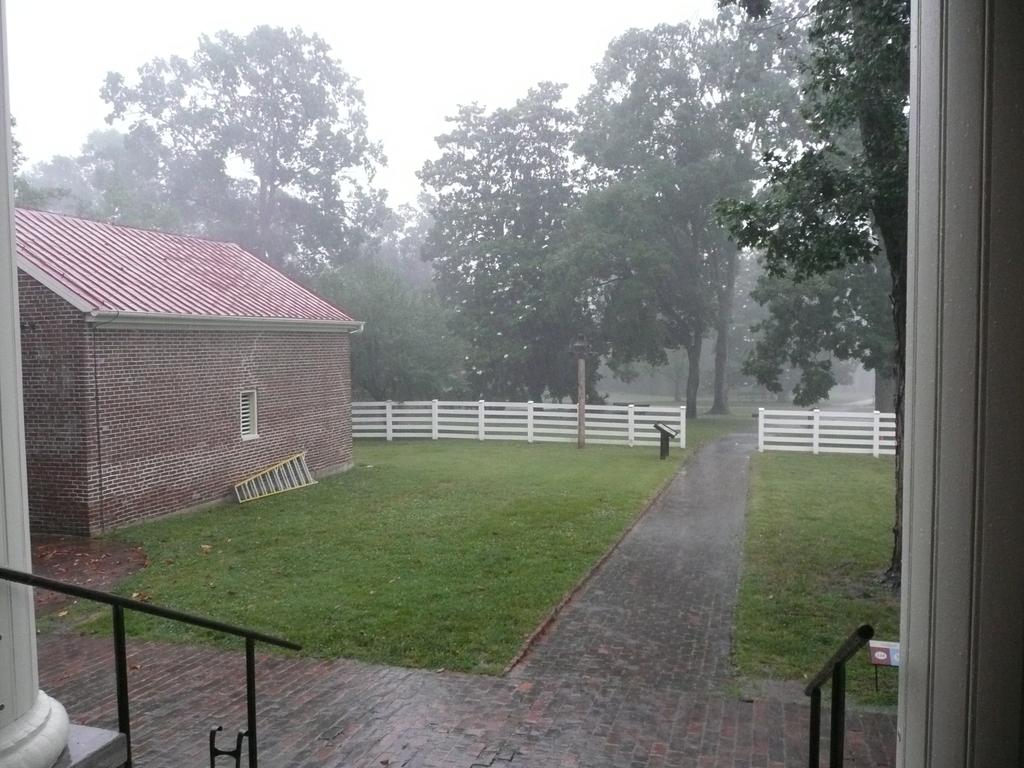What type of structure is in the picture? There is a house in the picture. What architectural features can be seen in the picture? There are pillars in the picture. What is used for climbing or reaching higher places in the picture? There is a ladder in the picture. What type of barrier is present in the picture? There is a fence in the picture. What type of vegetation is in the picture? There are trees in the picture. What is visible in the background of the picture? The sky is visible in the background of the picture. What type of knee injury can be seen in the picture? There is no knee injury present in the picture; it features a house, pillars, a ladder, a fence, trees, and the sky. What type of jewel is being worn by the woman in the picture? There is no woman present in the picture, and therefore no jewelry can be observed. 